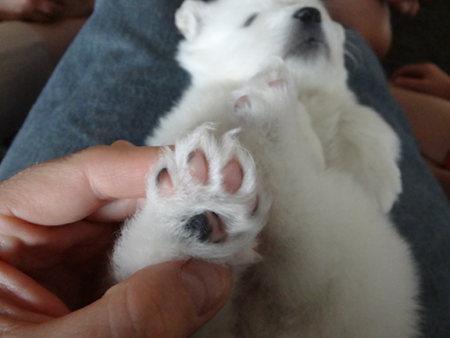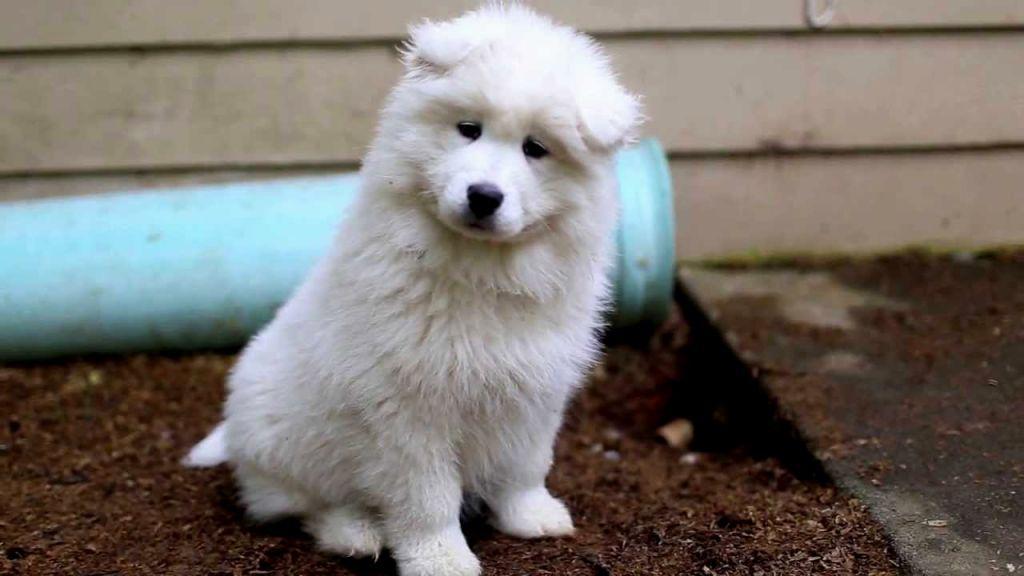The first image is the image on the left, the second image is the image on the right. For the images displayed, is the sentence "One of the white dogs is awake and with a person." factually correct? Answer yes or no. No. 